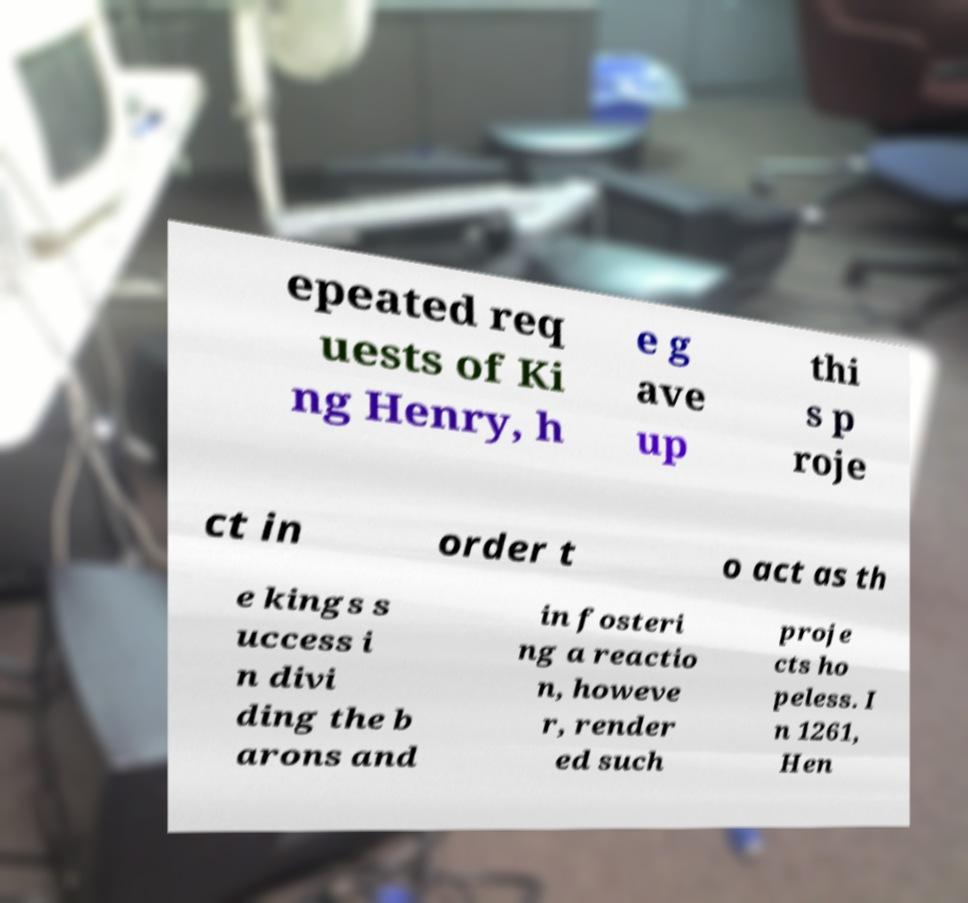Could you assist in decoding the text presented in this image and type it out clearly? epeated req uests of Ki ng Henry, h e g ave up thi s p roje ct in order t o act as th e kings s uccess i n divi ding the b arons and in fosteri ng a reactio n, howeve r, render ed such proje cts ho peless. I n 1261, Hen 